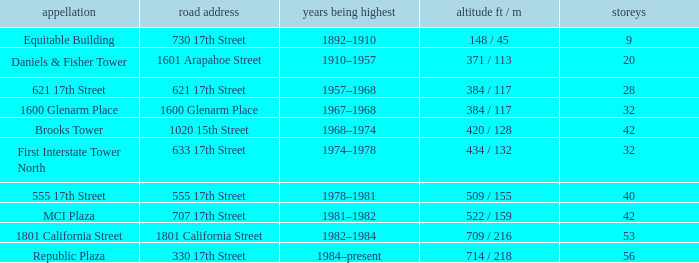What is the height of the building with 40 floors? 509 / 155. 